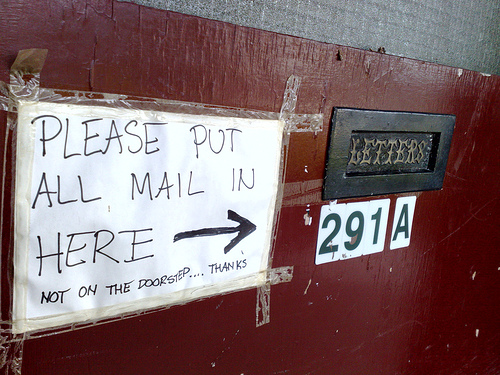<image>
Can you confirm if the notice is to the left of the wall? No. The notice is not to the left of the wall. From this viewpoint, they have a different horizontal relationship. 